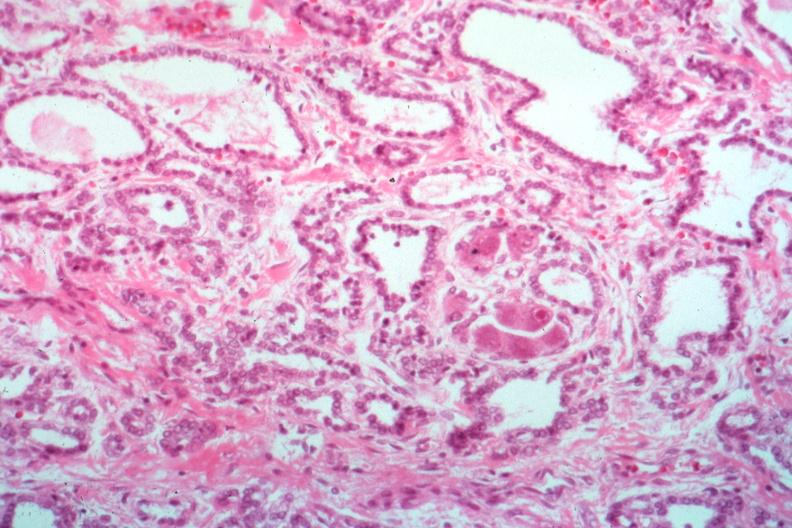where is this part in the figure?
Answer the question using a single word or phrase. Endocrine system 